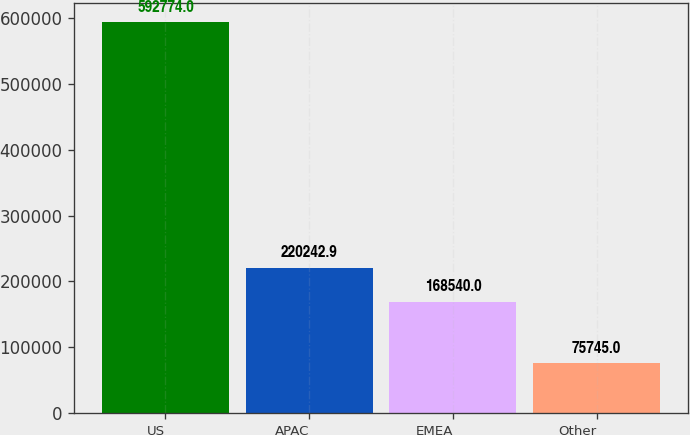Convert chart. <chart><loc_0><loc_0><loc_500><loc_500><bar_chart><fcel>US<fcel>APAC<fcel>EMEA<fcel>Other<nl><fcel>592774<fcel>220243<fcel>168540<fcel>75745<nl></chart> 